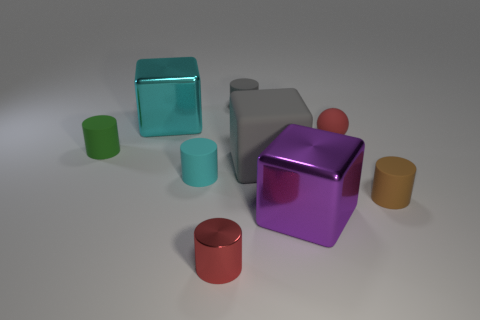What number of large metallic cubes are in front of the cyan block?
Give a very brief answer. 1. There is another object that is the same color as the tiny shiny object; what is its shape?
Your answer should be compact. Sphere. There is a matte cylinder behind the metallic thing behind the tiny green object; are there any gray rubber cylinders that are behind it?
Your answer should be compact. No. Do the cyan cube and the red cylinder have the same size?
Give a very brief answer. No. Is the number of green matte things behind the big gray thing the same as the number of big gray cubes right of the brown object?
Ensure brevity in your answer.  No. What shape is the red thing that is left of the purple block?
Make the answer very short. Cylinder. There is a gray object that is the same size as the brown rubber object; what shape is it?
Your answer should be very brief. Cylinder. There is a rubber cylinder right of the gray matte thing in front of the thing that is behind the cyan metallic thing; what color is it?
Keep it short and to the point. Brown. Do the brown object and the small gray rubber thing have the same shape?
Offer a terse response. Yes. Are there an equal number of small brown things that are behind the gray rubber cube and large purple blocks?
Provide a succinct answer. No. 